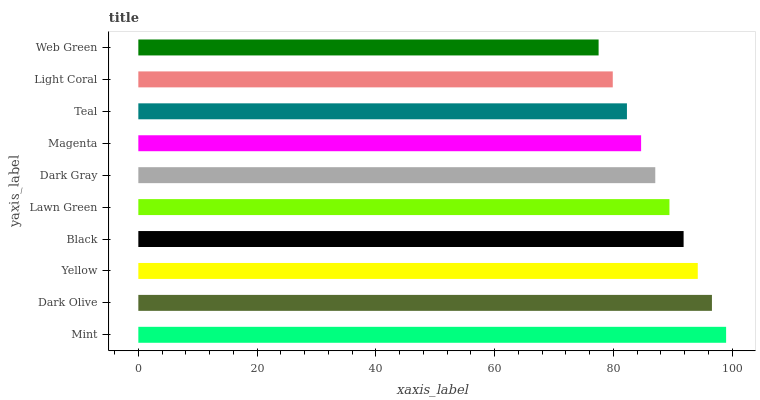Is Web Green the minimum?
Answer yes or no. Yes. Is Mint the maximum?
Answer yes or no. Yes. Is Dark Olive the minimum?
Answer yes or no. No. Is Dark Olive the maximum?
Answer yes or no. No. Is Mint greater than Dark Olive?
Answer yes or no. Yes. Is Dark Olive less than Mint?
Answer yes or no. Yes. Is Dark Olive greater than Mint?
Answer yes or no. No. Is Mint less than Dark Olive?
Answer yes or no. No. Is Lawn Green the high median?
Answer yes or no. Yes. Is Dark Gray the low median?
Answer yes or no. Yes. Is Magenta the high median?
Answer yes or no. No. Is Light Coral the low median?
Answer yes or no. No. 